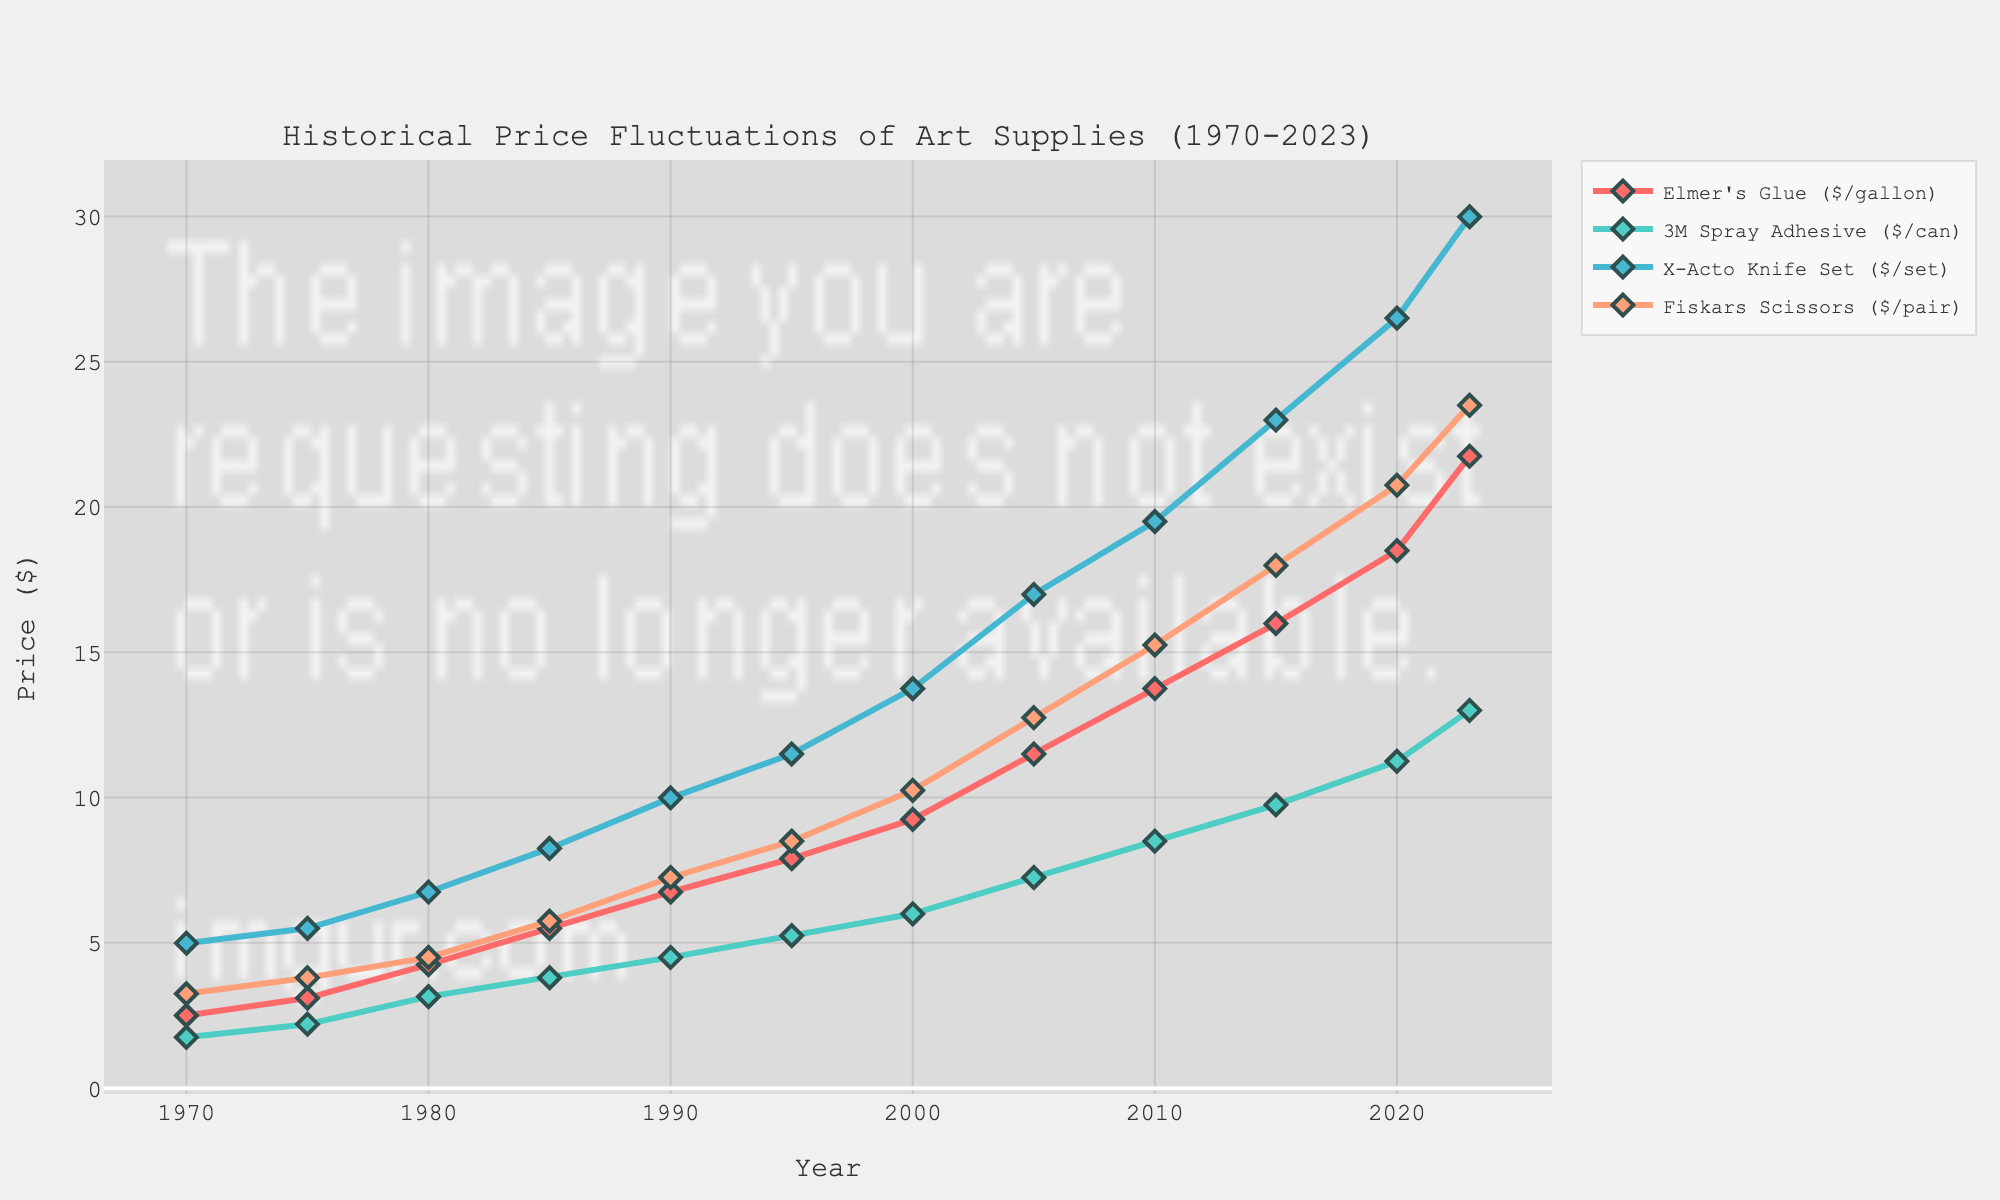Which year saw the highest price for Elmer's Glue? To determine the highest price for Elmer's Glue, we look for the year where its price is at its maximum value on the plotted line. The peak price is $21.75 in 2023, making it the year with the highest price.
Answer: 2023 How much did the price of 3M Spray Adhesive increase between 1970 and 2023? First, identify the price in 1970, which is $1.75, and the price in 2023, which is $13.00. Then, subtract the 1970 price from the 2023 price: $13.00 - $1.75 = $11.25.
Answer: $11.25 What is the visual difference between the lines representing Fiskars Scissors and X-Acto Knife Set prices in 2000? Locate the price points on the graph for Fiskars Scissors and X-Acto Knife Set in the year 2000. Fiskars Scissors are at $10.25 and X-Acto Knife Set is at $13.75. The visual difference is determined by the distance between these two points on the y-axis.
Answer: $3.50 Which art supply had the steadiest price increase over the period? Analyzing the slope consistency of each line, identify which line shows the least fluctuation and the most consistent upward trend. Elmer's Glue exhibits a steady increase with minimal fluctuation compared to others.
Answer: Elmer's Glue In which decade did the price of Fiskars Scissors increase the most? Examine the slope of Fiskars Scissors’ line segment for each decade to find the steepest incline. The largest increase occurred from 2010 ($15.25) to 2020 ($20.75), which is an increase of $5.50.
Answer: 2010s What is the average price of 3M Spray Adhesive over the full period? Sum up all the listed prices of 3M Spray Adhesive and divide by the number of years provided. The prices are summed as follows: $1.75 + $2.20 + $3.15 + $3.80 + $4.50 + $5.25 + $6.00 + $7.25 + $8.50 + $9.75 + $11.25 + $13.00 = $76.40. Dividing by 12 years gives $76.40 / 12 ≈ $6.37.
Answer: $6.37 By what factor did the price of the X-Acto Knife Set increase from 1970 to 2023? Determine the initial price in 1970 ($4.99) and the final price in 2023 ($29.99). Divide the final price by the initial price to get the factor of increase: $29.99 / $4.99 ≈ 6.01.
Answer: 6.01 If the price trends continue, estimate the price of Elmer's Glue in 2025. Calculate the annual increase in the recent years and then project it forward. Between 2020 and 2023, the increase is from $18.50 to $21.75 which is $3.25 over 3 years. This gives an average annual increase of $3.25 / 3 ≈ $1.08. Adding two years' increase ($2.16) to the 2023 price: $21.75 + $2.16 ≈ $23.91.
Answer: $23.91 